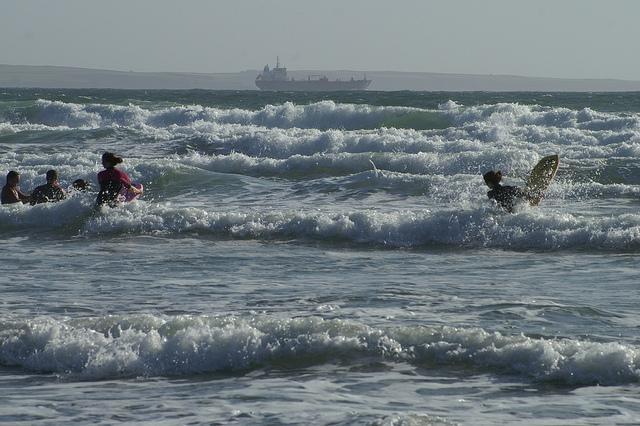What activity is taking place besides surfing?
Choose the correct response, then elucidate: 'Answer: answer
Rationale: rationale.'
Options: Fishing, paddling, swimming, canoeing. Answer: swimming.
Rationale: There are people in the water that are swimming and aren't using any equipment. 